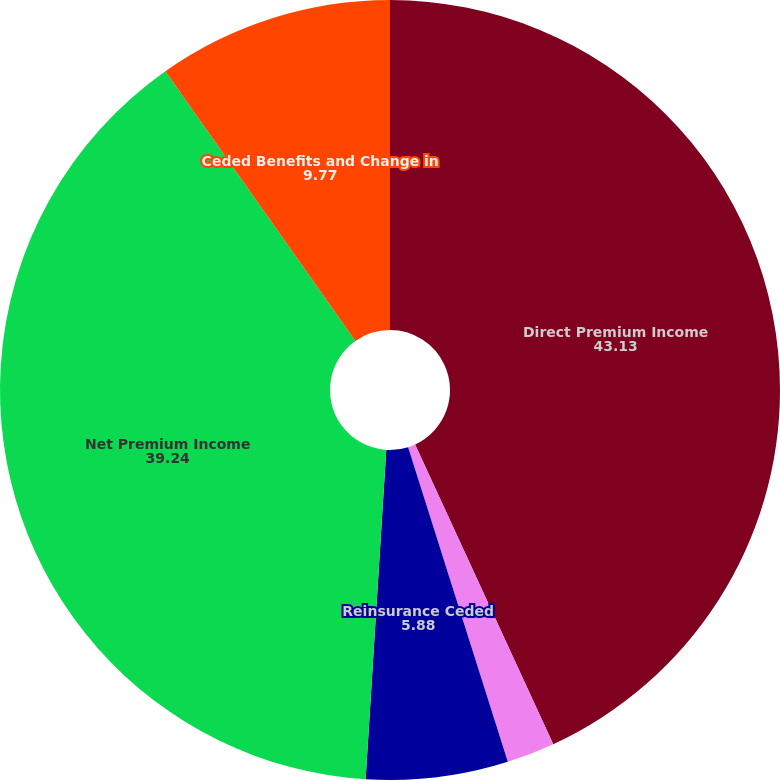Convert chart. <chart><loc_0><loc_0><loc_500><loc_500><pie_chart><fcel>Direct Premium Income<fcel>Reinsurance Assumed<fcel>Reinsurance Ceded<fcel>Net Premium Income<fcel>Ceded Benefits and Change in<nl><fcel>43.13%<fcel>1.99%<fcel>5.88%<fcel>39.24%<fcel>9.77%<nl></chart> 